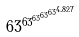<formula> <loc_0><loc_0><loc_500><loc_500>6 3 ^ { 6 3 ^ { 6 3 ^ { 6 3 ^ { 6 3 ^ { 4 . 8 2 7 } } } } }</formula> 